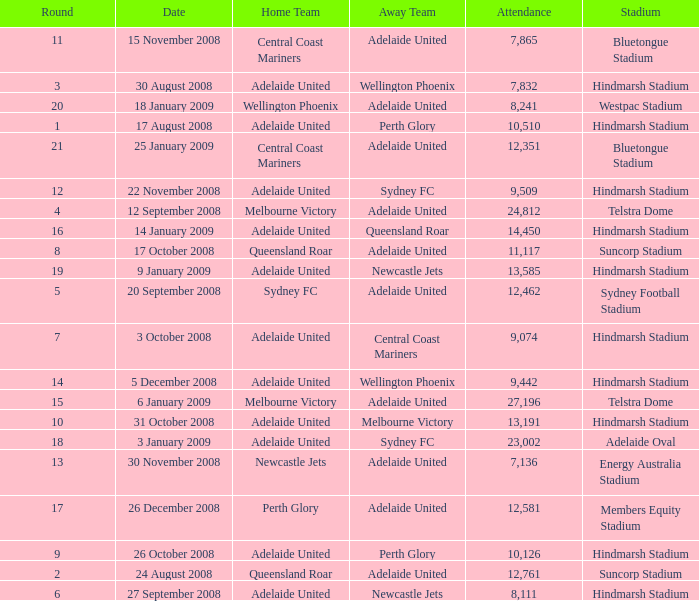What is the smallest round for the game played at members equity stadium in the presence of 12,581 attendees? None. 